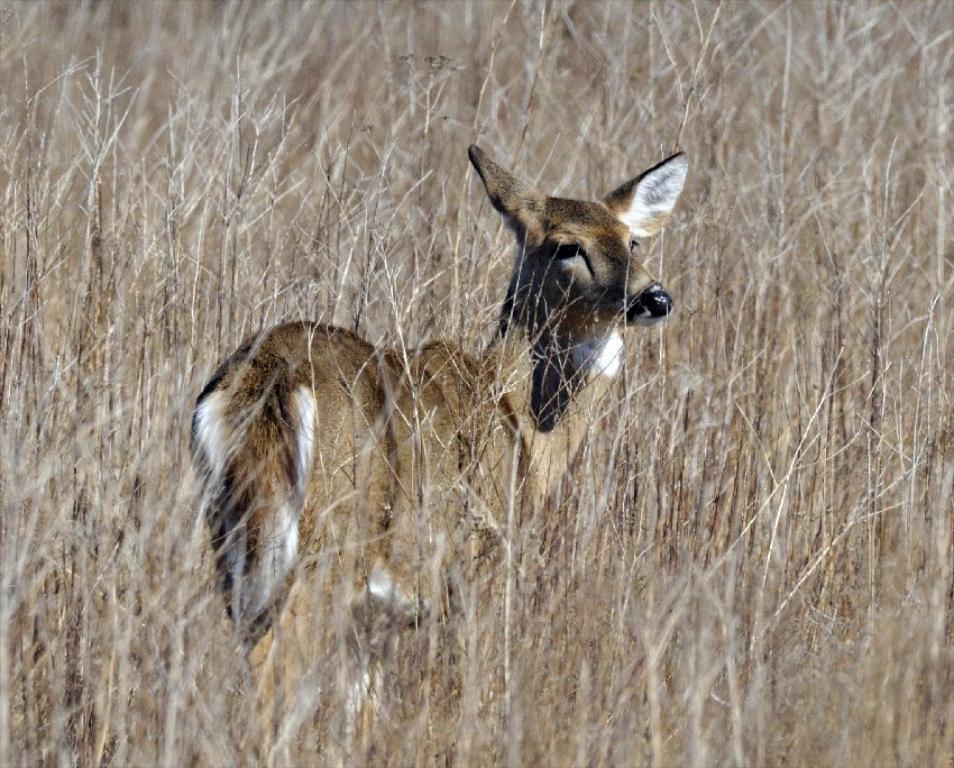Could you give a brief overview of what you see in this image? In this image we can see an animal and grass. 